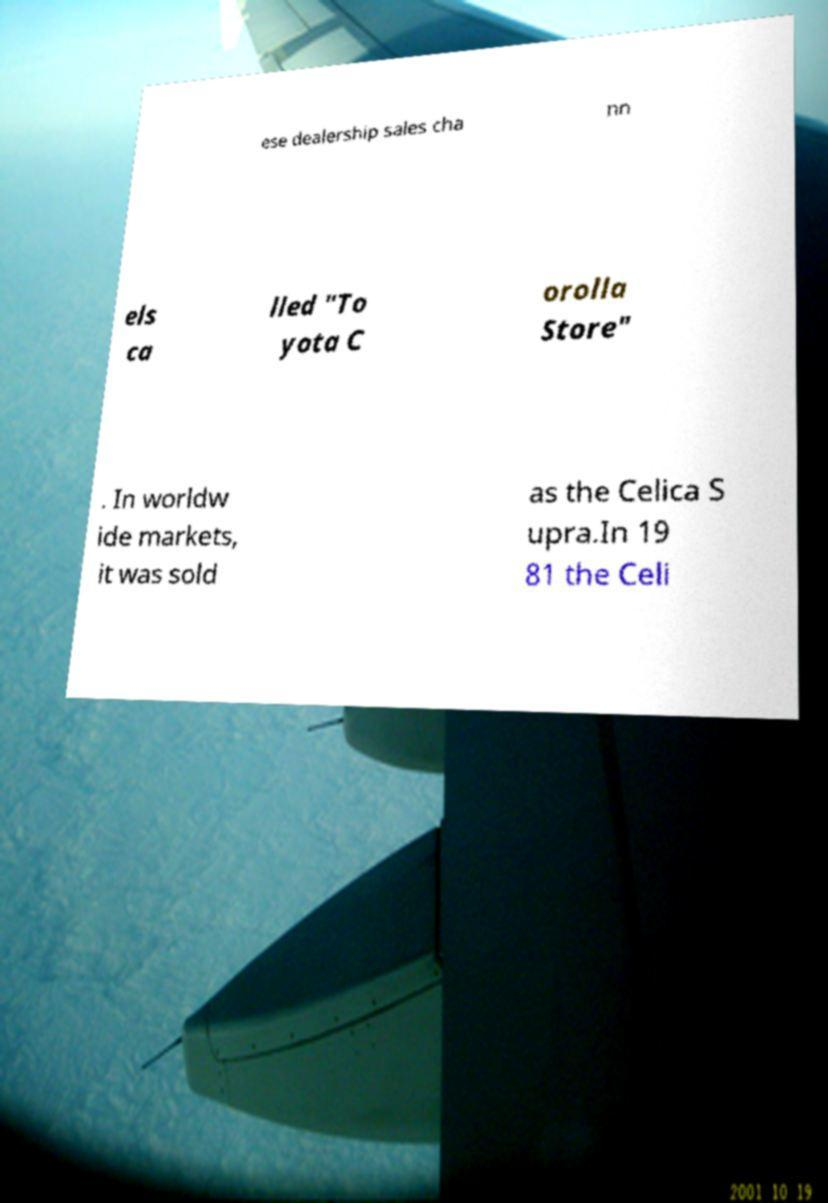Could you extract and type out the text from this image? ese dealership sales cha nn els ca lled "To yota C orolla Store" . In worldw ide markets, it was sold as the Celica S upra.In 19 81 the Celi 